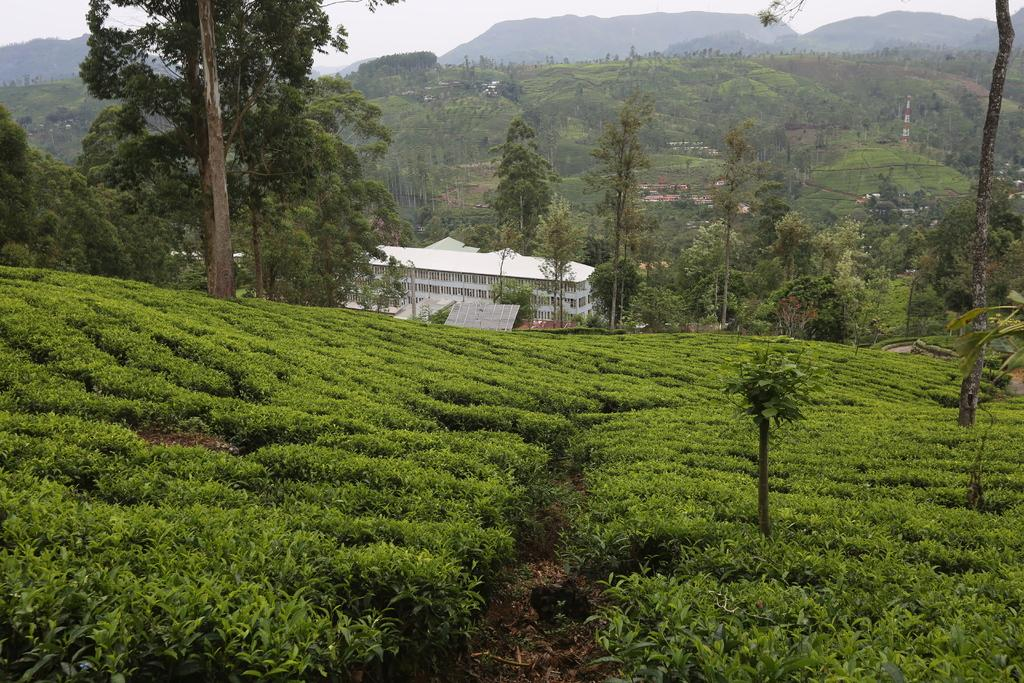What type of structure is visible in the image? There is a house in the image. What natural elements can be seen in the image? There are trees and hills in the image. How would you describe the weather in the image? The sky is cloudy in the image. Can you tell me how many pairs of scissors are hanging from the trees in the image? There are no scissors present in the image; it features a house, trees, and hills with a cloudy sky. 